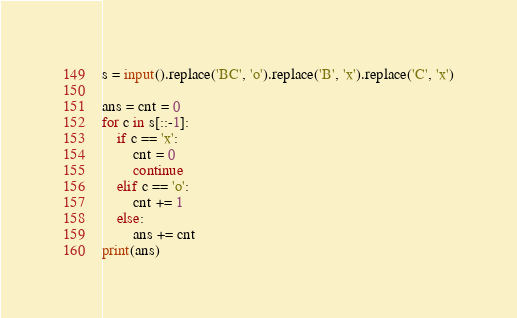<code> <loc_0><loc_0><loc_500><loc_500><_Python_>s = input().replace('BC', 'o').replace('B', 'x').replace('C', 'x')

ans = cnt = 0
for c in s[::-1]:
    if c == 'x':
        cnt = 0
        continue
    elif c == 'o':
        cnt += 1
    else:
        ans += cnt
print(ans)
</code> 